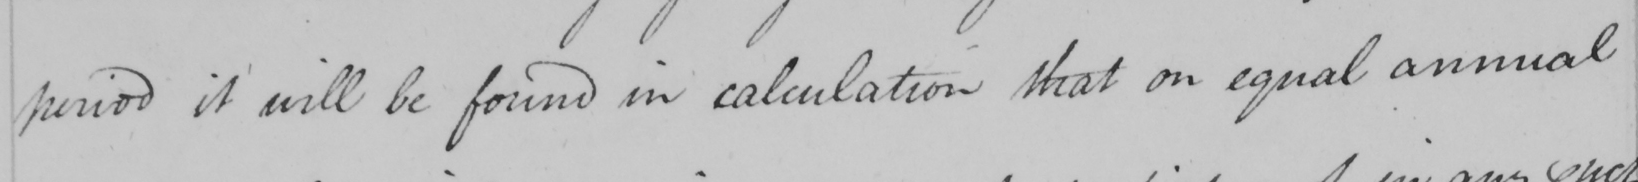Please transcribe the handwritten text in this image. period it will be found in calculation that on equal annual 